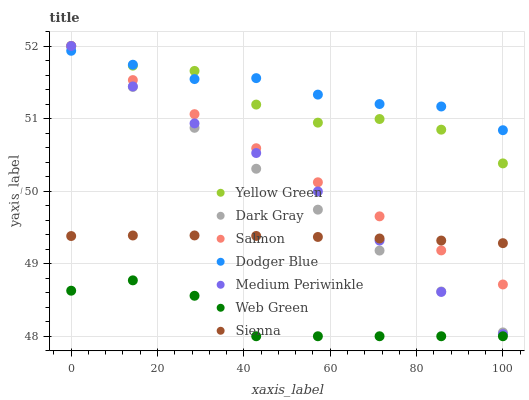Does Web Green have the minimum area under the curve?
Answer yes or no. Yes. Does Dodger Blue have the maximum area under the curve?
Answer yes or no. Yes. Does Yellow Green have the minimum area under the curve?
Answer yes or no. No. Does Yellow Green have the maximum area under the curve?
Answer yes or no. No. Is Salmon the smoothest?
Answer yes or no. Yes. Is Yellow Green the roughest?
Answer yes or no. Yes. Is Medium Periwinkle the smoothest?
Answer yes or no. No. Is Medium Periwinkle the roughest?
Answer yes or no. No. Does Web Green have the lowest value?
Answer yes or no. Yes. Does Yellow Green have the lowest value?
Answer yes or no. No. Does Dark Gray have the highest value?
Answer yes or no. Yes. Does Web Green have the highest value?
Answer yes or no. No. Is Web Green less than Salmon?
Answer yes or no. Yes. Is Dodger Blue greater than Sienna?
Answer yes or no. Yes. Does Salmon intersect Yellow Green?
Answer yes or no. Yes. Is Salmon less than Yellow Green?
Answer yes or no. No. Is Salmon greater than Yellow Green?
Answer yes or no. No. Does Web Green intersect Salmon?
Answer yes or no. No. 